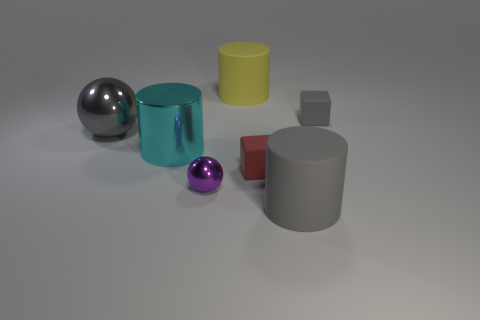Are there any other things that are the same size as the red thing?
Provide a succinct answer. Yes. Do the big yellow thing and the cyan shiny object have the same shape?
Provide a succinct answer. Yes. Is the material of the gray cylinder the same as the tiny purple sphere that is behind the large gray rubber cylinder?
Make the answer very short. No. What material is the cylinder that is to the right of the large yellow object?
Your response must be concise. Rubber. What is the size of the purple ball?
Offer a very short reply. Small. Does the block that is in front of the tiny gray rubber block have the same size as the gray thing that is behind the gray sphere?
Provide a succinct answer. Yes. There is a yellow matte object that is the same shape as the big cyan metal object; what size is it?
Ensure brevity in your answer.  Large. Do the gray metallic ball and the block in front of the large cyan thing have the same size?
Provide a short and direct response. No. Is there a small metallic object in front of the tiny gray rubber block that is behind the tiny red block?
Provide a succinct answer. Yes. There is a large gray object that is in front of the big metallic sphere; what shape is it?
Make the answer very short. Cylinder. 